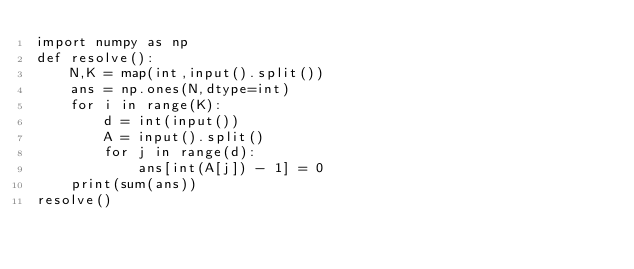<code> <loc_0><loc_0><loc_500><loc_500><_Python_>import numpy as np
def resolve():
    N,K = map(int,input().split())
    ans = np.ones(N,dtype=int)
    for i in range(K):
        d = int(input())
        A = input().split()
        for j in range(d):
            ans[int(A[j]) - 1] = 0
    print(sum(ans))
resolve()</code> 